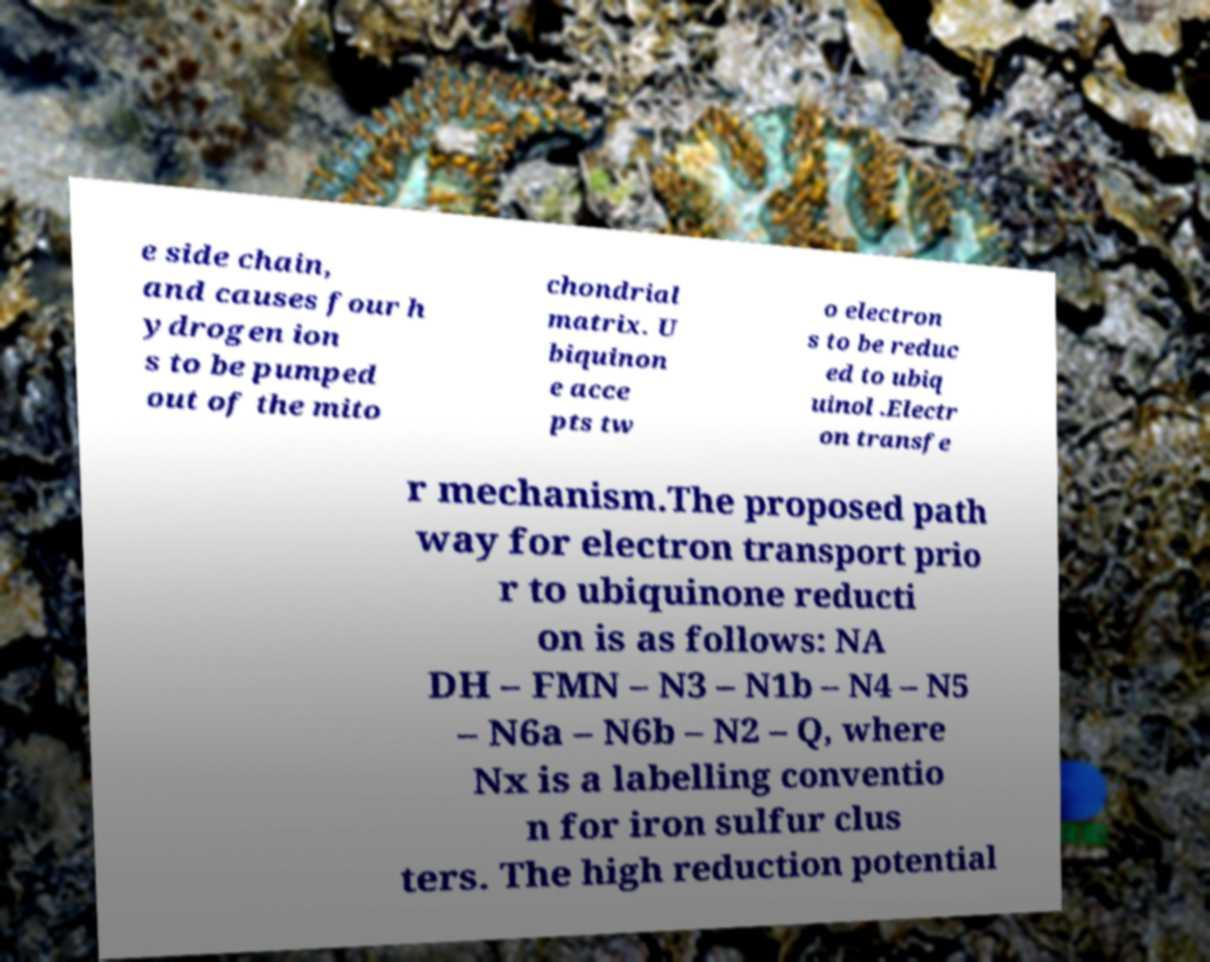What messages or text are displayed in this image? I need them in a readable, typed format. e side chain, and causes four h ydrogen ion s to be pumped out of the mito chondrial matrix. U biquinon e acce pts tw o electron s to be reduc ed to ubiq uinol .Electr on transfe r mechanism.The proposed path way for electron transport prio r to ubiquinone reducti on is as follows: NA DH – FMN – N3 – N1b – N4 – N5 – N6a – N6b – N2 – Q, where Nx is a labelling conventio n for iron sulfur clus ters. The high reduction potential 